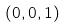Convert formula to latex. <formula><loc_0><loc_0><loc_500><loc_500>( 0 , 0 , 1 )</formula> 